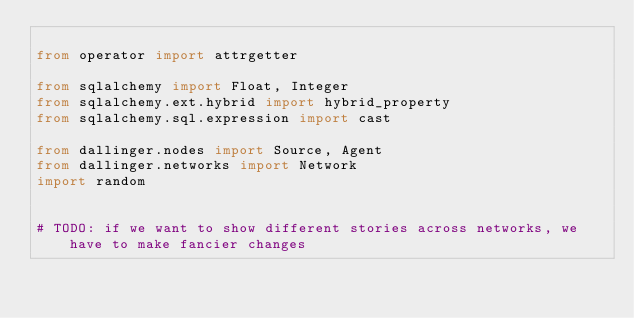Convert code to text. <code><loc_0><loc_0><loc_500><loc_500><_Python_>
from operator import attrgetter

from sqlalchemy import Float, Integer
from sqlalchemy.ext.hybrid import hybrid_property
from sqlalchemy.sql.expression import cast

from dallinger.nodes import Source, Agent
from dallinger.networks import Network
import random


# TODO: if we want to show different stories across networks, we have to make fancier changes </code> 